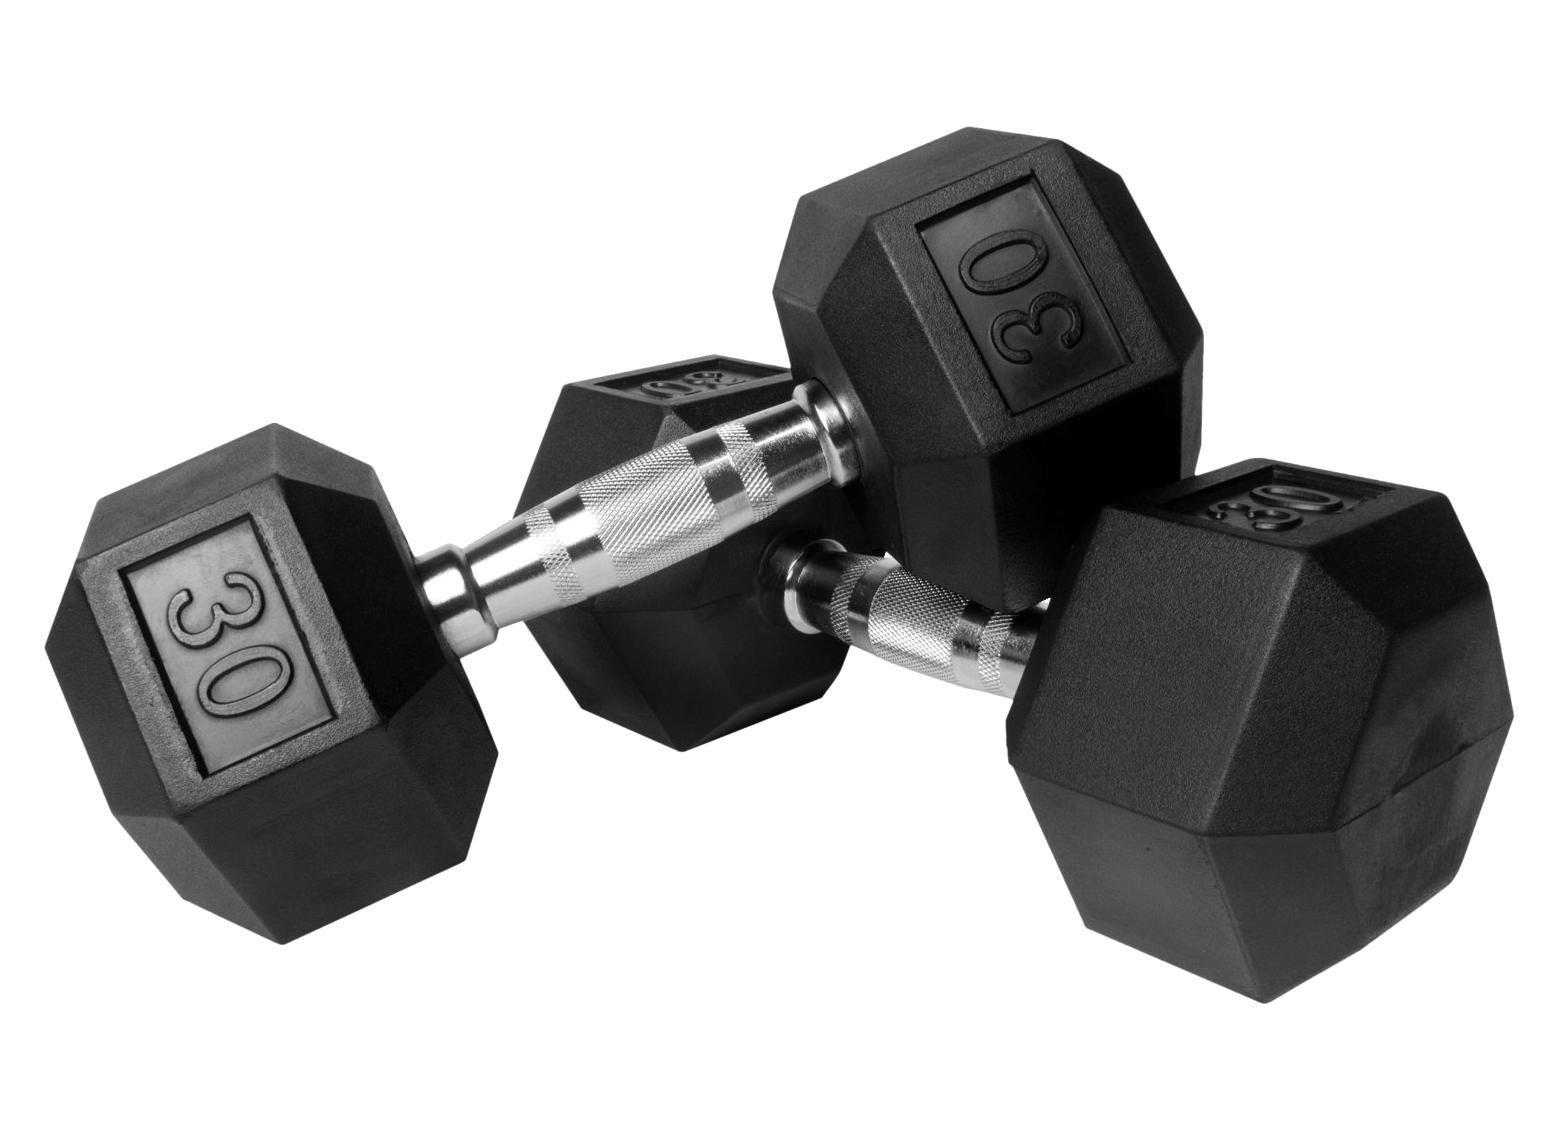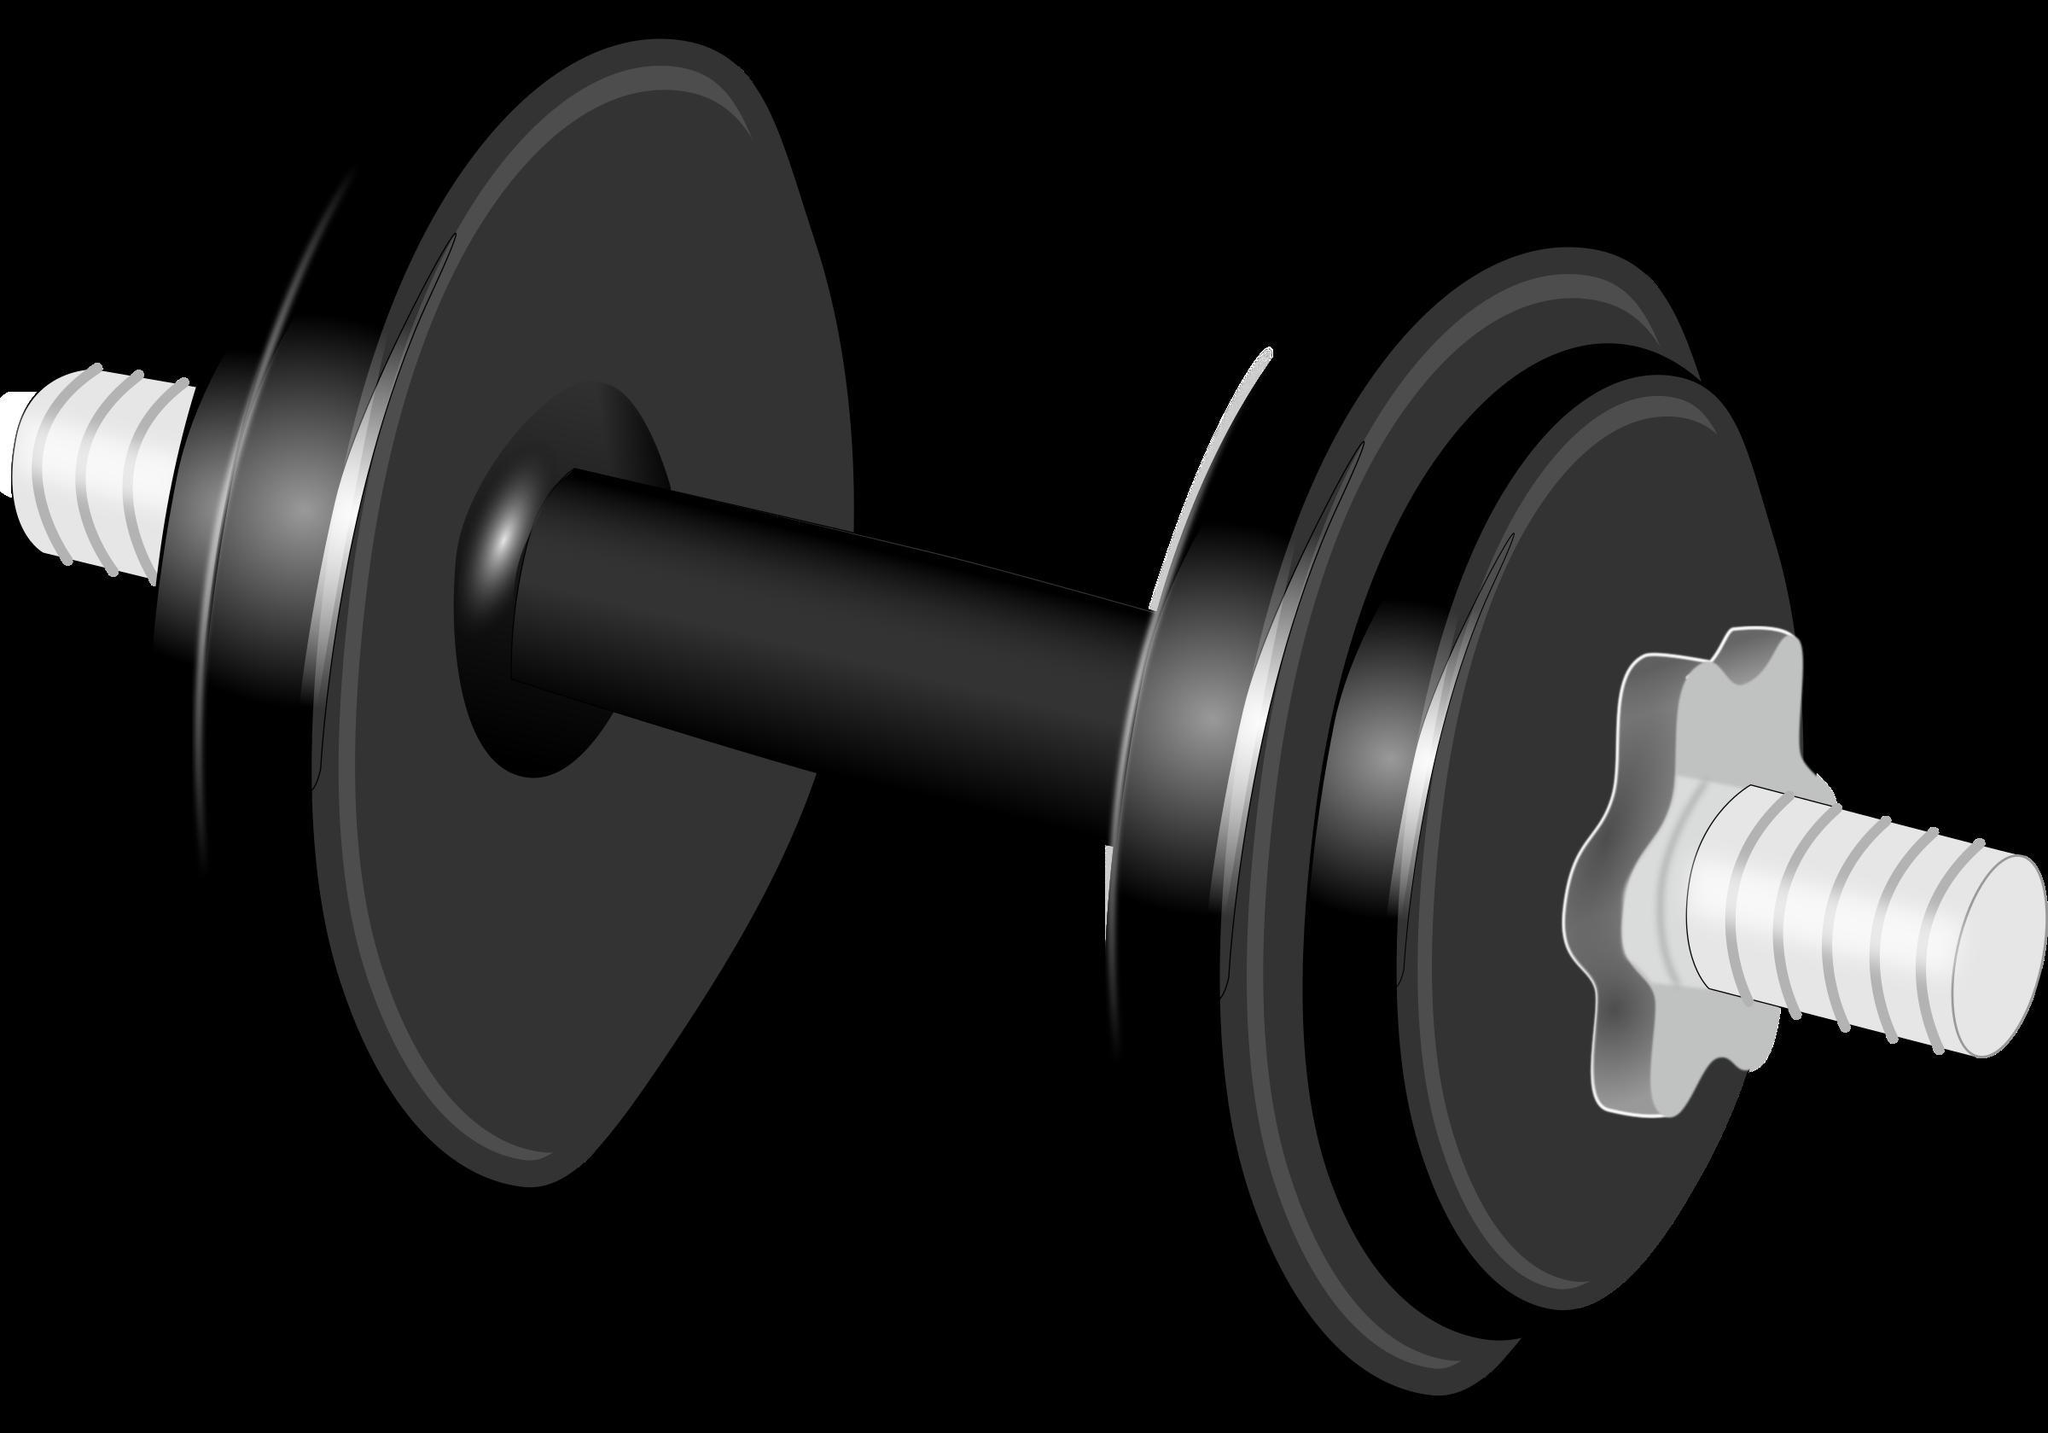The first image is the image on the left, the second image is the image on the right. Examine the images to the left and right. Is the description "All of the weights are green in both images." accurate? Answer yes or no. No. The first image is the image on the left, the second image is the image on the right. Examine the images to the left and right. Is the description "Images contain green dumbbells and contain the same number of dumbbells." accurate? Answer yes or no. No. 